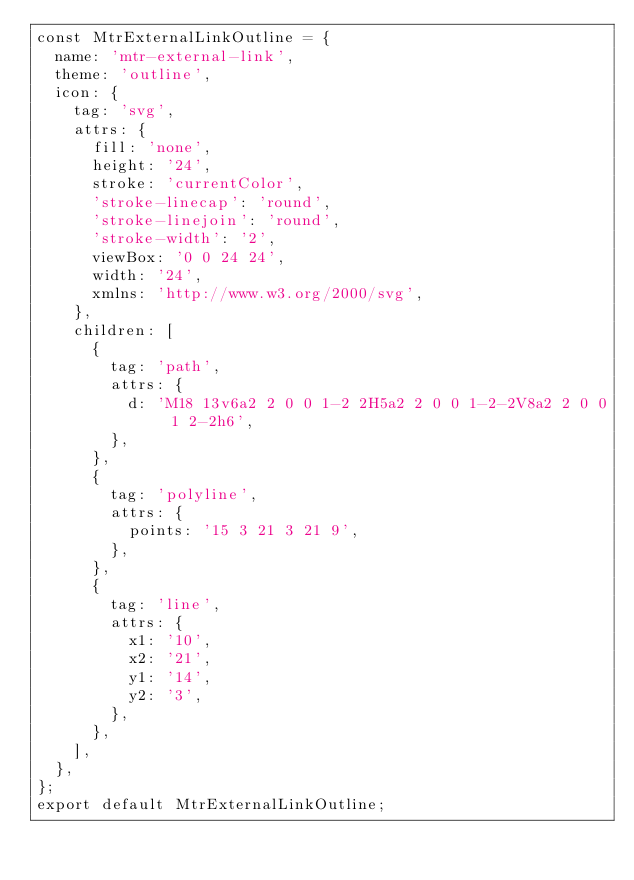Convert code to text. <code><loc_0><loc_0><loc_500><loc_500><_JavaScript_>const MtrExternalLinkOutline = {
  name: 'mtr-external-link',
  theme: 'outline',
  icon: {
    tag: 'svg',
    attrs: {
      fill: 'none',
      height: '24',
      stroke: 'currentColor',
      'stroke-linecap': 'round',
      'stroke-linejoin': 'round',
      'stroke-width': '2',
      viewBox: '0 0 24 24',
      width: '24',
      xmlns: 'http://www.w3.org/2000/svg',
    },
    children: [
      {
        tag: 'path',
        attrs: {
          d: 'M18 13v6a2 2 0 0 1-2 2H5a2 2 0 0 1-2-2V8a2 2 0 0 1 2-2h6',
        },
      },
      {
        tag: 'polyline',
        attrs: {
          points: '15 3 21 3 21 9',
        },
      },
      {
        tag: 'line',
        attrs: {
          x1: '10',
          x2: '21',
          y1: '14',
          y2: '3',
        },
      },
    ],
  },
};
export default MtrExternalLinkOutline;
</code> 